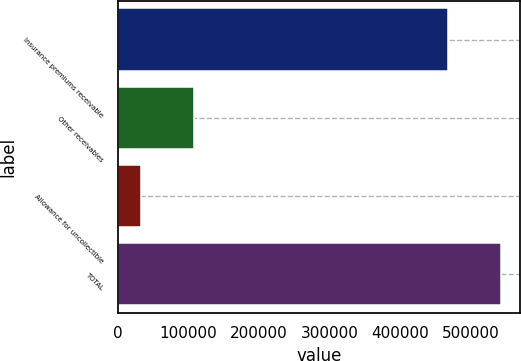Convert chart to OTSL. <chart><loc_0><loc_0><loc_500><loc_500><bar_chart><fcel>Insurance premiums receivable<fcel>Other receivables<fcel>Allowance for uncollectible<fcel>TOTAL<nl><fcel>468334<fcel>107721<fcel>33128<fcel>542927<nl></chart> 